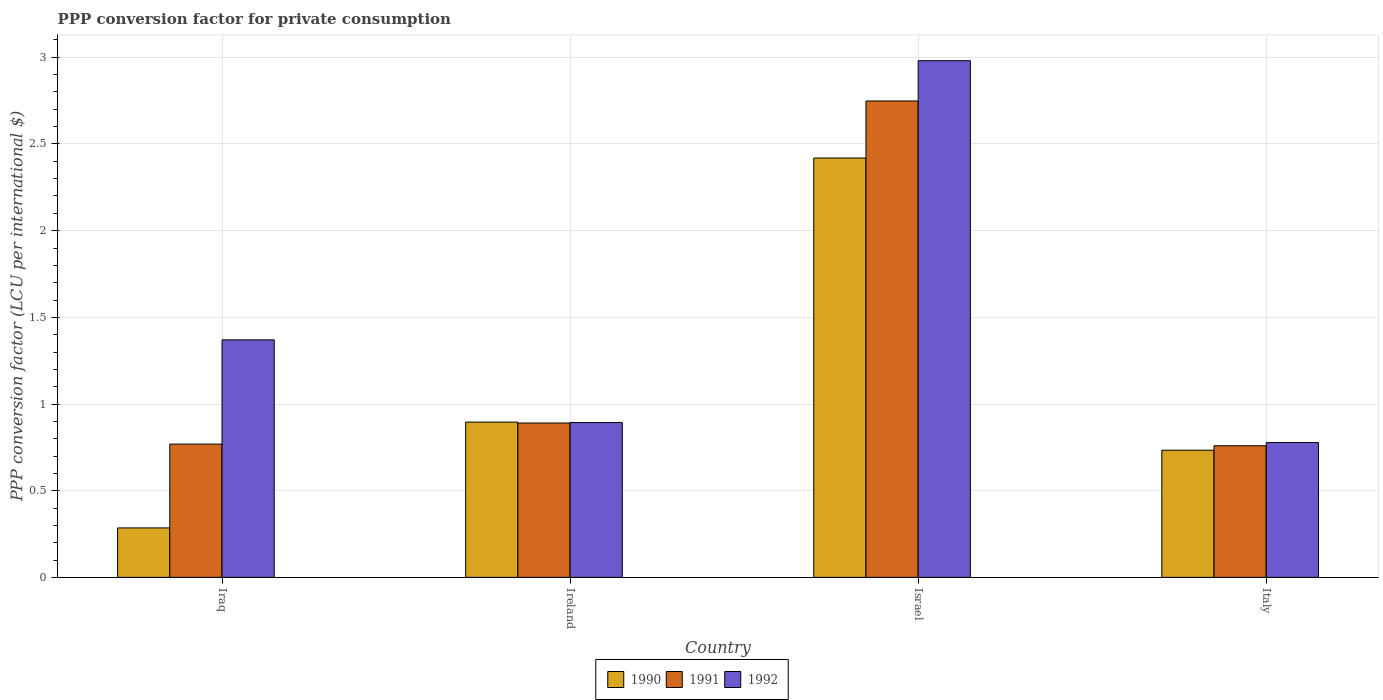Are the number of bars on each tick of the X-axis equal?
Ensure brevity in your answer.  Yes. How many bars are there on the 3rd tick from the left?
Your response must be concise. 3. How many bars are there on the 1st tick from the right?
Your answer should be compact. 3. What is the label of the 3rd group of bars from the left?
Provide a succinct answer. Israel. What is the PPP conversion factor for private consumption in 1991 in Iraq?
Offer a terse response. 0.77. Across all countries, what is the maximum PPP conversion factor for private consumption in 1992?
Offer a terse response. 2.98. Across all countries, what is the minimum PPP conversion factor for private consumption in 1991?
Give a very brief answer. 0.76. What is the total PPP conversion factor for private consumption in 1991 in the graph?
Offer a terse response. 5.17. What is the difference between the PPP conversion factor for private consumption in 1992 in Iraq and that in Ireland?
Offer a very short reply. 0.48. What is the difference between the PPP conversion factor for private consumption in 1991 in Italy and the PPP conversion factor for private consumption in 1990 in Iraq?
Offer a very short reply. 0.47. What is the average PPP conversion factor for private consumption in 1990 per country?
Provide a succinct answer. 1.08. What is the difference between the PPP conversion factor for private consumption of/in 1992 and PPP conversion factor for private consumption of/in 1991 in Israel?
Offer a terse response. 0.23. What is the ratio of the PPP conversion factor for private consumption in 1990 in Ireland to that in Israel?
Offer a very short reply. 0.37. Is the PPP conversion factor for private consumption in 1992 in Iraq less than that in Ireland?
Your response must be concise. No. What is the difference between the highest and the second highest PPP conversion factor for private consumption in 1992?
Your response must be concise. -0.48. What is the difference between the highest and the lowest PPP conversion factor for private consumption in 1990?
Ensure brevity in your answer.  2.13. Is the sum of the PPP conversion factor for private consumption in 1991 in Iraq and Israel greater than the maximum PPP conversion factor for private consumption in 1990 across all countries?
Make the answer very short. Yes. What does the 2nd bar from the left in Israel represents?
Your answer should be compact. 1991. What does the 3rd bar from the right in Israel represents?
Your answer should be compact. 1990. What is the difference between two consecutive major ticks on the Y-axis?
Ensure brevity in your answer.  0.5. Are the values on the major ticks of Y-axis written in scientific E-notation?
Give a very brief answer. No. Where does the legend appear in the graph?
Your response must be concise. Bottom center. What is the title of the graph?
Ensure brevity in your answer.  PPP conversion factor for private consumption. What is the label or title of the X-axis?
Your answer should be compact. Country. What is the label or title of the Y-axis?
Keep it short and to the point. PPP conversion factor (LCU per international $). What is the PPP conversion factor (LCU per international $) of 1990 in Iraq?
Keep it short and to the point. 0.29. What is the PPP conversion factor (LCU per international $) in 1991 in Iraq?
Keep it short and to the point. 0.77. What is the PPP conversion factor (LCU per international $) of 1992 in Iraq?
Ensure brevity in your answer.  1.37. What is the PPP conversion factor (LCU per international $) in 1990 in Ireland?
Offer a terse response. 0.9. What is the PPP conversion factor (LCU per international $) of 1991 in Ireland?
Provide a short and direct response. 0.89. What is the PPP conversion factor (LCU per international $) of 1992 in Ireland?
Offer a terse response. 0.89. What is the PPP conversion factor (LCU per international $) in 1990 in Israel?
Your answer should be very brief. 2.42. What is the PPP conversion factor (LCU per international $) in 1991 in Israel?
Offer a very short reply. 2.75. What is the PPP conversion factor (LCU per international $) in 1992 in Israel?
Offer a very short reply. 2.98. What is the PPP conversion factor (LCU per international $) in 1990 in Italy?
Your response must be concise. 0.73. What is the PPP conversion factor (LCU per international $) in 1991 in Italy?
Your response must be concise. 0.76. What is the PPP conversion factor (LCU per international $) in 1992 in Italy?
Your answer should be very brief. 0.78. Across all countries, what is the maximum PPP conversion factor (LCU per international $) in 1990?
Offer a terse response. 2.42. Across all countries, what is the maximum PPP conversion factor (LCU per international $) in 1991?
Ensure brevity in your answer.  2.75. Across all countries, what is the maximum PPP conversion factor (LCU per international $) in 1992?
Offer a terse response. 2.98. Across all countries, what is the minimum PPP conversion factor (LCU per international $) in 1990?
Your response must be concise. 0.29. Across all countries, what is the minimum PPP conversion factor (LCU per international $) of 1991?
Your answer should be very brief. 0.76. Across all countries, what is the minimum PPP conversion factor (LCU per international $) in 1992?
Make the answer very short. 0.78. What is the total PPP conversion factor (LCU per international $) in 1990 in the graph?
Keep it short and to the point. 4.33. What is the total PPP conversion factor (LCU per international $) of 1991 in the graph?
Your response must be concise. 5.17. What is the total PPP conversion factor (LCU per international $) in 1992 in the graph?
Provide a succinct answer. 6.02. What is the difference between the PPP conversion factor (LCU per international $) in 1990 in Iraq and that in Ireland?
Make the answer very short. -0.61. What is the difference between the PPP conversion factor (LCU per international $) in 1991 in Iraq and that in Ireland?
Keep it short and to the point. -0.12. What is the difference between the PPP conversion factor (LCU per international $) in 1992 in Iraq and that in Ireland?
Provide a short and direct response. 0.48. What is the difference between the PPP conversion factor (LCU per international $) in 1990 in Iraq and that in Israel?
Give a very brief answer. -2.13. What is the difference between the PPP conversion factor (LCU per international $) in 1991 in Iraq and that in Israel?
Make the answer very short. -1.98. What is the difference between the PPP conversion factor (LCU per international $) of 1992 in Iraq and that in Israel?
Ensure brevity in your answer.  -1.61. What is the difference between the PPP conversion factor (LCU per international $) of 1990 in Iraq and that in Italy?
Your response must be concise. -0.45. What is the difference between the PPP conversion factor (LCU per international $) of 1991 in Iraq and that in Italy?
Provide a short and direct response. 0.01. What is the difference between the PPP conversion factor (LCU per international $) of 1992 in Iraq and that in Italy?
Keep it short and to the point. 0.59. What is the difference between the PPP conversion factor (LCU per international $) in 1990 in Ireland and that in Israel?
Offer a terse response. -1.52. What is the difference between the PPP conversion factor (LCU per international $) in 1991 in Ireland and that in Israel?
Your answer should be very brief. -1.86. What is the difference between the PPP conversion factor (LCU per international $) of 1992 in Ireland and that in Israel?
Ensure brevity in your answer.  -2.09. What is the difference between the PPP conversion factor (LCU per international $) in 1990 in Ireland and that in Italy?
Your answer should be very brief. 0.16. What is the difference between the PPP conversion factor (LCU per international $) of 1991 in Ireland and that in Italy?
Provide a short and direct response. 0.13. What is the difference between the PPP conversion factor (LCU per international $) of 1992 in Ireland and that in Italy?
Make the answer very short. 0.12. What is the difference between the PPP conversion factor (LCU per international $) of 1990 in Israel and that in Italy?
Provide a succinct answer. 1.69. What is the difference between the PPP conversion factor (LCU per international $) of 1991 in Israel and that in Italy?
Your answer should be very brief. 1.99. What is the difference between the PPP conversion factor (LCU per international $) of 1992 in Israel and that in Italy?
Offer a terse response. 2.2. What is the difference between the PPP conversion factor (LCU per international $) of 1990 in Iraq and the PPP conversion factor (LCU per international $) of 1991 in Ireland?
Offer a very short reply. -0.61. What is the difference between the PPP conversion factor (LCU per international $) of 1990 in Iraq and the PPP conversion factor (LCU per international $) of 1992 in Ireland?
Offer a terse response. -0.61. What is the difference between the PPP conversion factor (LCU per international $) of 1991 in Iraq and the PPP conversion factor (LCU per international $) of 1992 in Ireland?
Keep it short and to the point. -0.12. What is the difference between the PPP conversion factor (LCU per international $) in 1990 in Iraq and the PPP conversion factor (LCU per international $) in 1991 in Israel?
Make the answer very short. -2.46. What is the difference between the PPP conversion factor (LCU per international $) in 1990 in Iraq and the PPP conversion factor (LCU per international $) in 1992 in Israel?
Keep it short and to the point. -2.7. What is the difference between the PPP conversion factor (LCU per international $) of 1991 in Iraq and the PPP conversion factor (LCU per international $) of 1992 in Israel?
Make the answer very short. -2.21. What is the difference between the PPP conversion factor (LCU per international $) of 1990 in Iraq and the PPP conversion factor (LCU per international $) of 1991 in Italy?
Provide a short and direct response. -0.47. What is the difference between the PPP conversion factor (LCU per international $) in 1990 in Iraq and the PPP conversion factor (LCU per international $) in 1992 in Italy?
Your response must be concise. -0.49. What is the difference between the PPP conversion factor (LCU per international $) in 1991 in Iraq and the PPP conversion factor (LCU per international $) in 1992 in Italy?
Give a very brief answer. -0.01. What is the difference between the PPP conversion factor (LCU per international $) in 1990 in Ireland and the PPP conversion factor (LCU per international $) in 1991 in Israel?
Your answer should be very brief. -1.85. What is the difference between the PPP conversion factor (LCU per international $) in 1990 in Ireland and the PPP conversion factor (LCU per international $) in 1992 in Israel?
Give a very brief answer. -2.08. What is the difference between the PPP conversion factor (LCU per international $) of 1991 in Ireland and the PPP conversion factor (LCU per international $) of 1992 in Israel?
Keep it short and to the point. -2.09. What is the difference between the PPP conversion factor (LCU per international $) of 1990 in Ireland and the PPP conversion factor (LCU per international $) of 1991 in Italy?
Provide a succinct answer. 0.14. What is the difference between the PPP conversion factor (LCU per international $) in 1990 in Ireland and the PPP conversion factor (LCU per international $) in 1992 in Italy?
Keep it short and to the point. 0.12. What is the difference between the PPP conversion factor (LCU per international $) of 1991 in Ireland and the PPP conversion factor (LCU per international $) of 1992 in Italy?
Keep it short and to the point. 0.11. What is the difference between the PPP conversion factor (LCU per international $) in 1990 in Israel and the PPP conversion factor (LCU per international $) in 1991 in Italy?
Give a very brief answer. 1.66. What is the difference between the PPP conversion factor (LCU per international $) in 1990 in Israel and the PPP conversion factor (LCU per international $) in 1992 in Italy?
Your answer should be very brief. 1.64. What is the difference between the PPP conversion factor (LCU per international $) of 1991 in Israel and the PPP conversion factor (LCU per international $) of 1992 in Italy?
Your answer should be very brief. 1.97. What is the average PPP conversion factor (LCU per international $) of 1991 per country?
Make the answer very short. 1.29. What is the average PPP conversion factor (LCU per international $) in 1992 per country?
Keep it short and to the point. 1.51. What is the difference between the PPP conversion factor (LCU per international $) of 1990 and PPP conversion factor (LCU per international $) of 1991 in Iraq?
Make the answer very short. -0.48. What is the difference between the PPP conversion factor (LCU per international $) of 1990 and PPP conversion factor (LCU per international $) of 1992 in Iraq?
Give a very brief answer. -1.08. What is the difference between the PPP conversion factor (LCU per international $) in 1991 and PPP conversion factor (LCU per international $) in 1992 in Iraq?
Your answer should be compact. -0.6. What is the difference between the PPP conversion factor (LCU per international $) in 1990 and PPP conversion factor (LCU per international $) in 1991 in Ireland?
Provide a short and direct response. 0.01. What is the difference between the PPP conversion factor (LCU per international $) in 1990 and PPP conversion factor (LCU per international $) in 1992 in Ireland?
Your answer should be very brief. 0. What is the difference between the PPP conversion factor (LCU per international $) in 1991 and PPP conversion factor (LCU per international $) in 1992 in Ireland?
Offer a very short reply. -0. What is the difference between the PPP conversion factor (LCU per international $) in 1990 and PPP conversion factor (LCU per international $) in 1991 in Israel?
Keep it short and to the point. -0.33. What is the difference between the PPP conversion factor (LCU per international $) of 1990 and PPP conversion factor (LCU per international $) of 1992 in Israel?
Give a very brief answer. -0.56. What is the difference between the PPP conversion factor (LCU per international $) of 1991 and PPP conversion factor (LCU per international $) of 1992 in Israel?
Ensure brevity in your answer.  -0.23. What is the difference between the PPP conversion factor (LCU per international $) in 1990 and PPP conversion factor (LCU per international $) in 1991 in Italy?
Give a very brief answer. -0.03. What is the difference between the PPP conversion factor (LCU per international $) in 1990 and PPP conversion factor (LCU per international $) in 1992 in Italy?
Offer a very short reply. -0.04. What is the difference between the PPP conversion factor (LCU per international $) in 1991 and PPP conversion factor (LCU per international $) in 1992 in Italy?
Your answer should be compact. -0.02. What is the ratio of the PPP conversion factor (LCU per international $) of 1990 in Iraq to that in Ireland?
Your answer should be very brief. 0.32. What is the ratio of the PPP conversion factor (LCU per international $) of 1991 in Iraq to that in Ireland?
Your answer should be compact. 0.86. What is the ratio of the PPP conversion factor (LCU per international $) in 1992 in Iraq to that in Ireland?
Provide a short and direct response. 1.53. What is the ratio of the PPP conversion factor (LCU per international $) of 1990 in Iraq to that in Israel?
Provide a succinct answer. 0.12. What is the ratio of the PPP conversion factor (LCU per international $) in 1991 in Iraq to that in Israel?
Your response must be concise. 0.28. What is the ratio of the PPP conversion factor (LCU per international $) in 1992 in Iraq to that in Israel?
Keep it short and to the point. 0.46. What is the ratio of the PPP conversion factor (LCU per international $) of 1990 in Iraq to that in Italy?
Provide a succinct answer. 0.39. What is the ratio of the PPP conversion factor (LCU per international $) of 1991 in Iraq to that in Italy?
Provide a short and direct response. 1.01. What is the ratio of the PPP conversion factor (LCU per international $) of 1992 in Iraq to that in Italy?
Offer a terse response. 1.76. What is the ratio of the PPP conversion factor (LCU per international $) of 1990 in Ireland to that in Israel?
Your answer should be very brief. 0.37. What is the ratio of the PPP conversion factor (LCU per international $) in 1991 in Ireland to that in Israel?
Provide a succinct answer. 0.32. What is the ratio of the PPP conversion factor (LCU per international $) of 1992 in Ireland to that in Israel?
Offer a terse response. 0.3. What is the ratio of the PPP conversion factor (LCU per international $) in 1990 in Ireland to that in Italy?
Your response must be concise. 1.22. What is the ratio of the PPP conversion factor (LCU per international $) of 1991 in Ireland to that in Italy?
Offer a very short reply. 1.17. What is the ratio of the PPP conversion factor (LCU per international $) of 1992 in Ireland to that in Italy?
Provide a short and direct response. 1.15. What is the ratio of the PPP conversion factor (LCU per international $) of 1990 in Israel to that in Italy?
Offer a terse response. 3.3. What is the ratio of the PPP conversion factor (LCU per international $) in 1991 in Israel to that in Italy?
Offer a terse response. 3.62. What is the ratio of the PPP conversion factor (LCU per international $) in 1992 in Israel to that in Italy?
Ensure brevity in your answer.  3.83. What is the difference between the highest and the second highest PPP conversion factor (LCU per international $) in 1990?
Offer a very short reply. 1.52. What is the difference between the highest and the second highest PPP conversion factor (LCU per international $) of 1991?
Ensure brevity in your answer.  1.86. What is the difference between the highest and the second highest PPP conversion factor (LCU per international $) of 1992?
Give a very brief answer. 1.61. What is the difference between the highest and the lowest PPP conversion factor (LCU per international $) in 1990?
Ensure brevity in your answer.  2.13. What is the difference between the highest and the lowest PPP conversion factor (LCU per international $) of 1991?
Your answer should be compact. 1.99. What is the difference between the highest and the lowest PPP conversion factor (LCU per international $) of 1992?
Ensure brevity in your answer.  2.2. 